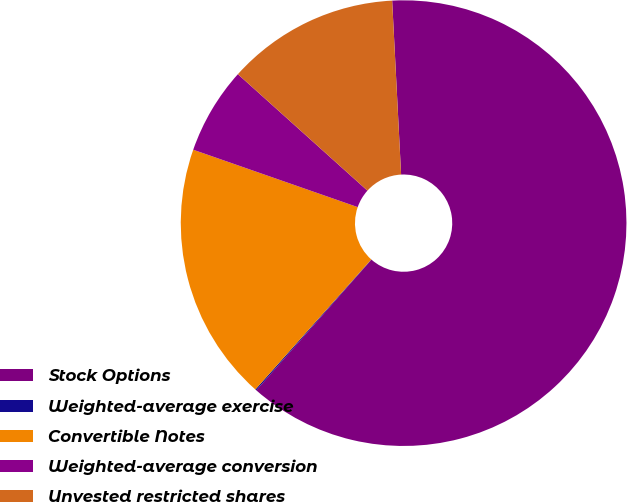<chart> <loc_0><loc_0><loc_500><loc_500><pie_chart><fcel>Stock Options<fcel>Weighted-average exercise<fcel>Convertible Notes<fcel>Weighted-average conversion<fcel>Unvested restricted shares<nl><fcel>62.32%<fcel>0.09%<fcel>18.76%<fcel>6.31%<fcel>12.53%<nl></chart> 